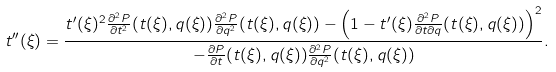Convert formula to latex. <formula><loc_0><loc_0><loc_500><loc_500>t ^ { \prime \prime } ( \xi ) = \frac { t ^ { \prime } ( \xi ) ^ { 2 } \frac { \partial ^ { 2 } P } { \partial t ^ { 2 } } ( t ( \xi ) , q ( \xi ) ) \frac { \partial ^ { 2 } P } { \partial q ^ { 2 } } ( t ( \xi ) , q ( \xi ) ) - \left ( 1 - t ^ { \prime } ( \xi ) \frac { \partial ^ { 2 } P } { \partial t \partial q } ( t ( \xi ) , q ( \xi ) ) \right ) ^ { 2 } } { - \frac { \partial P } { \partial t } ( t ( \xi ) , q ( \xi ) ) \frac { \partial ^ { 2 } P } { \partial q ^ { 2 } } ( t ( \xi ) , q ( \xi ) ) } .</formula> 